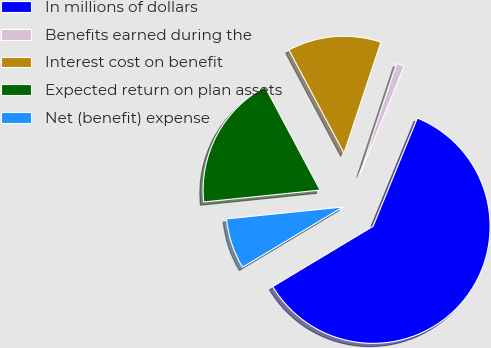Convert chart to OTSL. <chart><loc_0><loc_0><loc_500><loc_500><pie_chart><fcel>In millions of dollars<fcel>Benefits earned during the<fcel>Interest cost on benefit<fcel>Expected return on plan assets<fcel>Net (benefit) expense<nl><fcel>60.21%<fcel>1.08%<fcel>12.9%<fcel>18.82%<fcel>6.99%<nl></chart> 